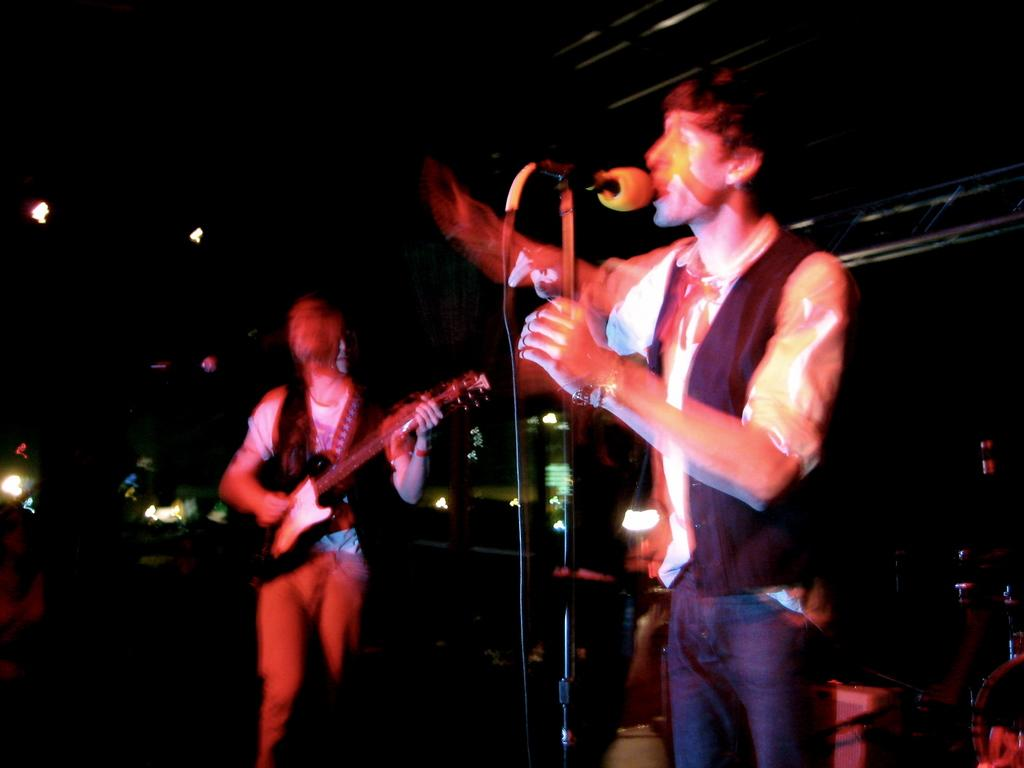What is the person on the right side of the image doing? The person on the right is singing. What object is the person on the right using while singing? The person on the right is in front of a microphone. What is the person on the left side of the image doing? The person on the left is playing a guitar. What type of polish is the person on the right applying to their nails in the image? There is no indication in the image that the person on the right is applying any polish to their nails. 